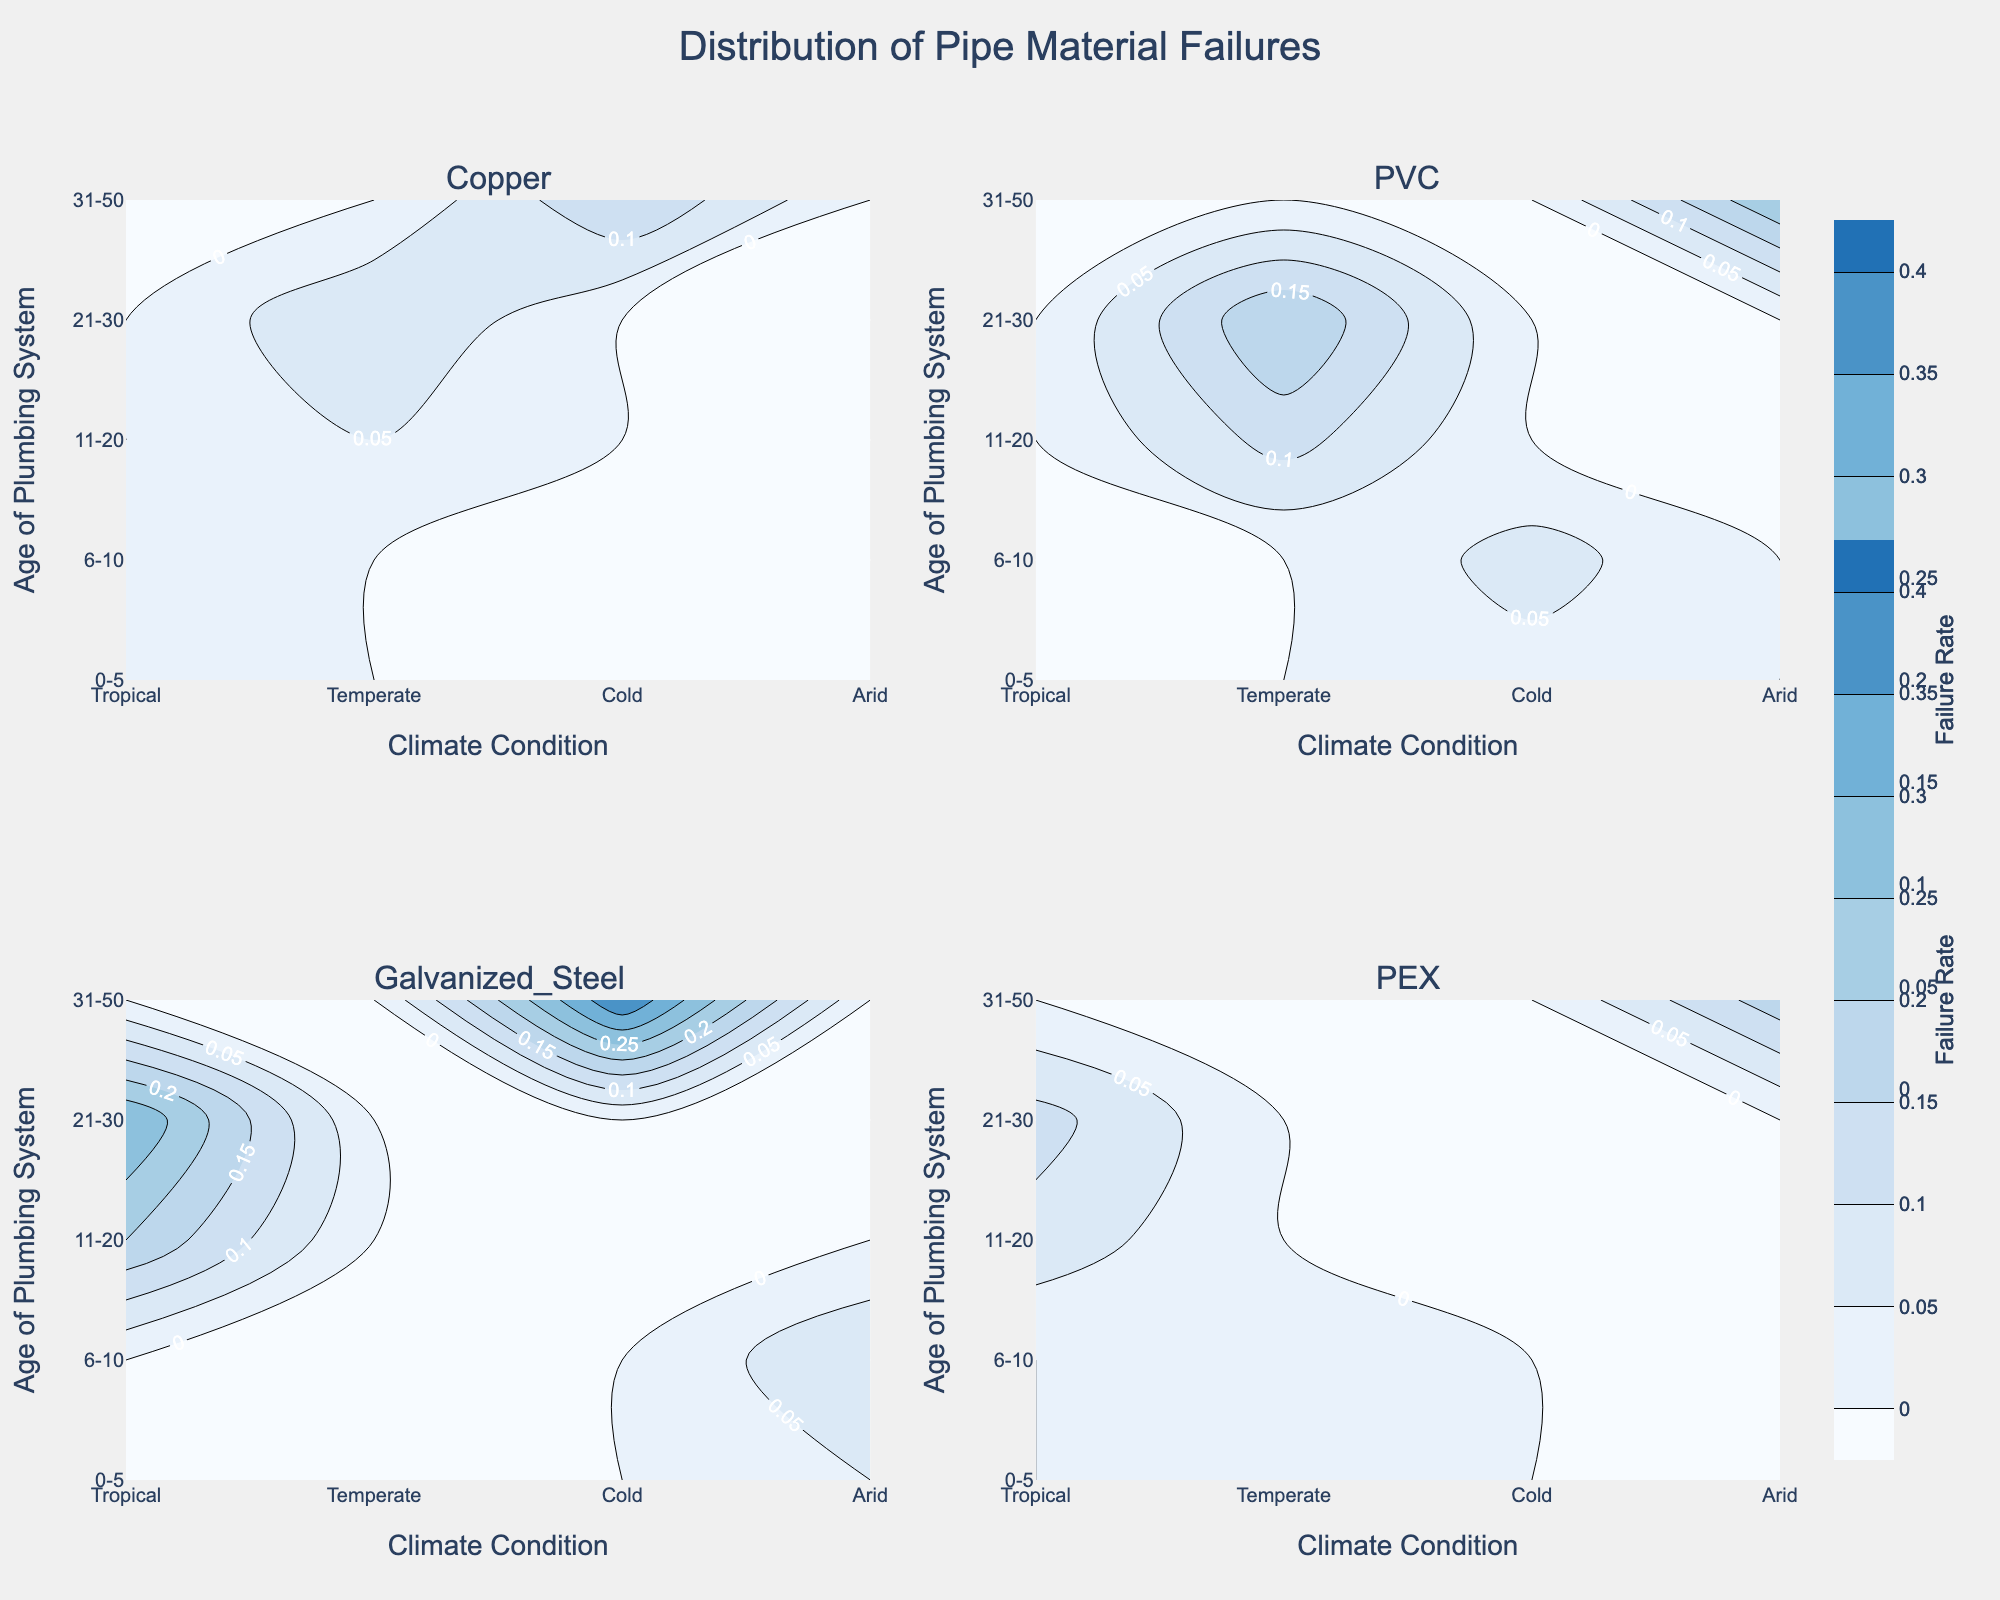What is the title of the figure? The title of the figure is located at the top center and reads "Distribution of Pipe Material Failures."
Answer: Distribution of Pipe Material Failures Which pipe material has the highest rate of failure for plumbing systems aged 31-50? Look at the subplot for each pipe material and find the contour with the highest value in the age group 31-50. Galvanized Steel in cold climates reaches a failure rate of 0.40.
Answer: Galvanized Steel How does the failure rate for PVC pipes in climates labeled as 'Cold’ vary across the age groups? Locate the PVC subplot and observe the failure rates along the 'Cold' climate condition for different age groups. The failure rates are: 0.03 (0-5), 0.07 (6-10), 0.12 (11-20), and 0.25 (31-50).
Answer: 0.03, 0.07, 0.12, 0.25 In which age group and climate condition do Copper pipes show the highest failure rate? Look at the Copper subplot and find the highest contour value among all combinations of age groups and climate conditions. The highest failure rate is 0.15 in the age group 31-50 in cold climates.
Answer: 31-50, Cold Compare the failure rates of PEX pipes and Copper pipes in tropical climates for plumbing systems aged 21-30. Which one is higher? Locate the failure rates for PEX and Copper in tropical climates and age group 21-30. For PEX, the rate is 0.12, while for Copper, there is no data point. Hence, no comparison can be made.
Answer: PEX, cannot compare What trend do you observe in the failure rate of Galvanized Steel pipes as the age of the plumbing system increases? Observe the Galvanized Steel subplot and note the general trend of failure rates across increasing age groups. The failure rate consistently increases with age, reaching 0.40 for the oldest age group.
Answer: Increases with age Which climate condition has the lowest rate of failure for Copper pipes across all age groups? Check the Copper subplot to determine the lowest failure rates across all age groups for every climate condition. The lowest failure rate is 0.01 in tropical climates.
Answer: Tropical How does the failure rate of PEX pipes in temperate climates change across the different age groups? Refer to the PEX subplot, focus on temperate climates, and observe the failure rates for each age group. The rates are: 0.02 (0-5), 0.05 (6-10).
Answer: 0.02, 0.05 What is the difference in failure rate between PVC pipes and Galvanized Steel pipes in arid climates for plumbing systems aged 0-5? Look at the PVC and Galvanized Steel subplots for arid climates and age group 0-5, noting the respective failure rates (0.03 for PVC, 0.05 for Galvanized Steel). Subtract the failure rate of PVC from Galvanized Steel: 0.05 - 0.03 = 0.02.
Answer: 0.02 For which pipe material and in what age group is the lowest failure rate observed? Look across all subplots and find the lowest failure rate for any combination of material and age group. The lowest rate is 0.01 for Copper in the 0-5 age group.
Answer: Copper, 0-5 